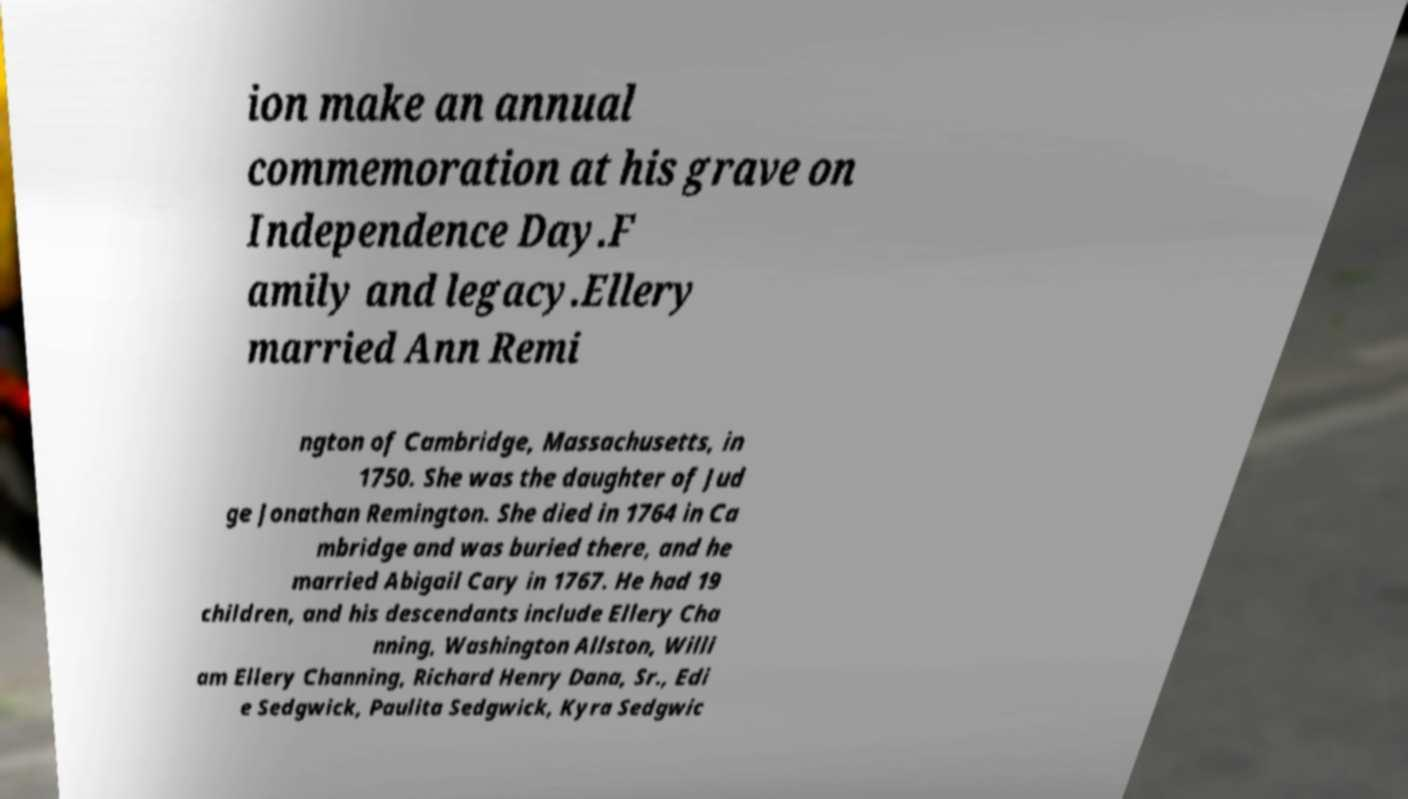Please identify and transcribe the text found in this image. ion make an annual commemoration at his grave on Independence Day.F amily and legacy.Ellery married Ann Remi ngton of Cambridge, Massachusetts, in 1750. She was the daughter of Jud ge Jonathan Remington. She died in 1764 in Ca mbridge and was buried there, and he married Abigail Cary in 1767. He had 19 children, and his descendants include Ellery Cha nning, Washington Allston, Willi am Ellery Channing, Richard Henry Dana, Sr., Edi e Sedgwick, Paulita Sedgwick, Kyra Sedgwic 